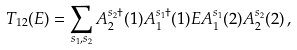Convert formula to latex. <formula><loc_0><loc_0><loc_500><loc_500>T _ { 1 2 } ( E ) = \sum _ { s _ { 1 } , s _ { 2 } } A ^ { s _ { 2 } \dagger } _ { 2 } ( 1 ) A _ { 1 } ^ { s _ { 1 } \dagger } ( 1 ) E A _ { 1 } ^ { s _ { 1 } } ( 2 ) A ^ { s _ { 2 } } _ { 2 } ( 2 ) \, ,</formula> 